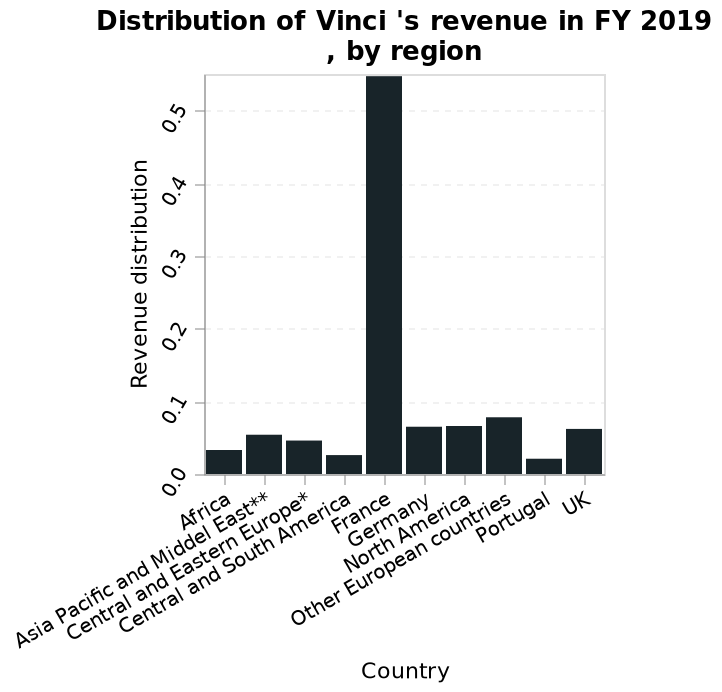<image>
What does the x-axis of the bar graph represent? The x-axis of the bar graph represents the countries. Were there any disasters where more than 300 people died? No What does each bar on the graph represent? Each bar on the graph represents the revenue distribution of Vinci in a specific country. What does the y-axis of the bar graph represent? The y-axis of the bar graph represents the revenue distribution. please summary the statistics and relations of the chart france was distributed the most revenue. Portugal was distributed the least. all but france were distrubeted below 0.1. Which country was distributed the least revenue?  Portugal 